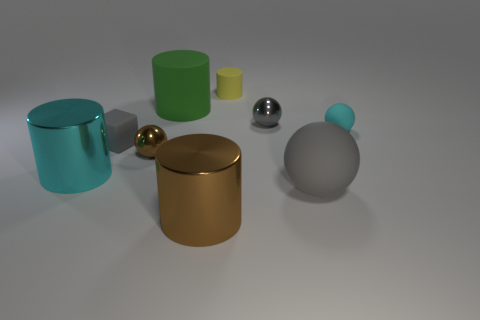How many other objects are the same shape as the small yellow rubber thing? There is one object that has the same cylindrical shape as the small yellow object; it is the larger green object on the left. 